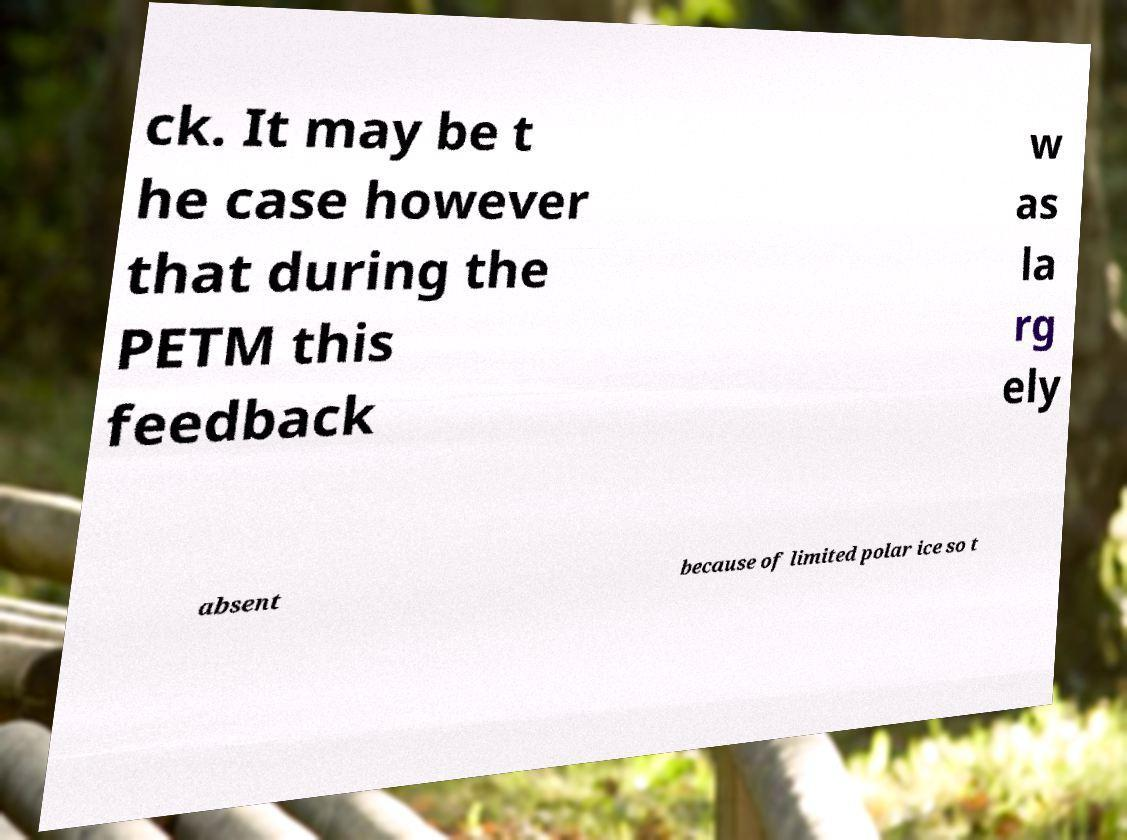Could you extract and type out the text from this image? ck. It may be t he case however that during the PETM this feedback w as la rg ely absent because of limited polar ice so t 